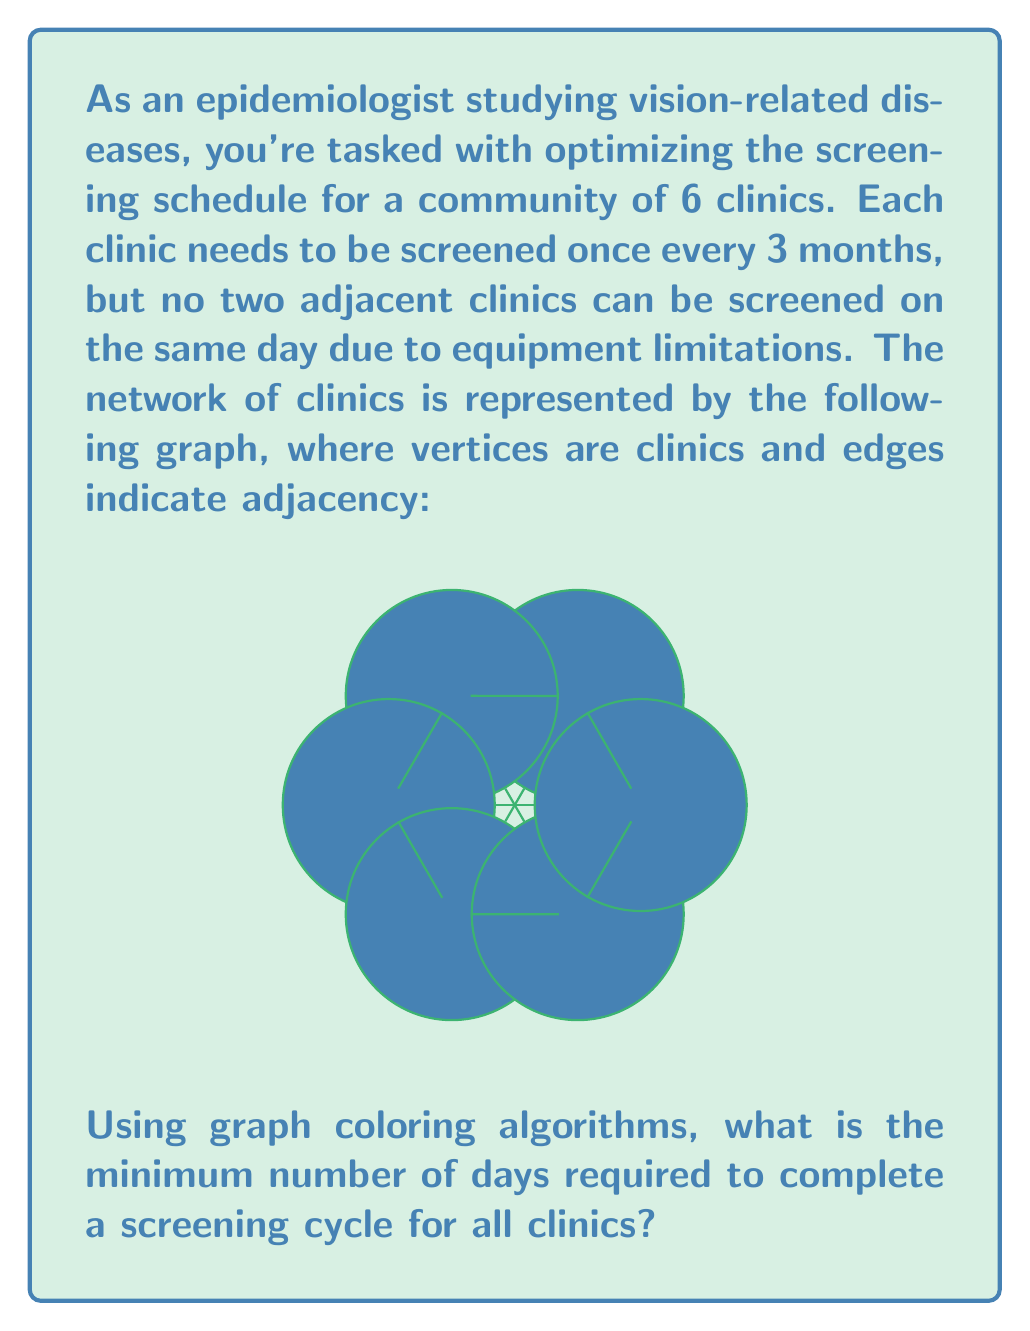Teach me how to tackle this problem. To solve this problem, we can use graph coloring algorithms. Each color in the graph will represent a different screening day. The goal is to find the chromatic number of the graph, which is the minimum number of colors needed to color the vertices such that no two adjacent vertices have the same color.

Step 1: Analyze the graph structure
The graph is a complete graph K6 (all vertices are connected to each other), which means we need at least 6 colors to properly color it.

Step 2: Apply the chromatic number theorem
For a complete graph Kn, the chromatic number χ(Kn) = n. In this case, χ(K6) = 6.

Step 3: Interpret the result
Each color represents a unique screening day. Since we need 6 colors, we require 6 different days to screen all clinics without scheduling adjacent clinics on the same day.

Step 4: Verify the solution
We can assign the colors (days) as follows:
C1: Day 1
C2: Day 2
C3: Day 3
C4: Day 4
C5: Day 5
C6: Day 6

This coloring ensures that no two adjacent clinics are screened on the same day.

Step 5: Consider the time constraint
The question states that each clinic needs to be screened once every 3 months. With 6 screening days, we can complete one full cycle in 6 days, which easily satisfies the 3-month requirement.

Therefore, the minimum number of days required to complete a screening cycle for all clinics is 6 days.
Answer: 6 days 